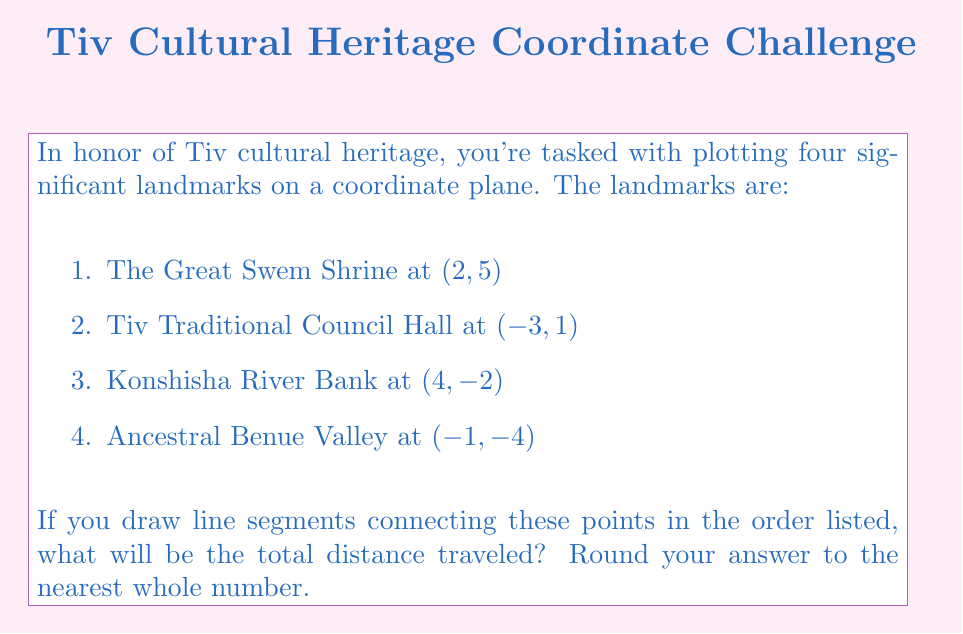Give your solution to this math problem. To solve this problem, we need to calculate the distances between consecutive points and sum them up. We'll use the distance formula between two points $(x_1, y_1)$ and $(x_2, y_2)$:

$$d = \sqrt{(x_2 - x_1)^2 + (y_2 - y_1)^2}$$

Let's calculate each distance:

1. From Great Swem Shrine (2, 5) to Tiv Traditional Council Hall (-3, 1):
   $$d_1 = \sqrt{(-3 - 2)^2 + (1 - 5)^2} = \sqrt{(-5)^2 + (-4)^2} = \sqrt{25 + 16} = \sqrt{41} \approx 6.40$$

2. From Tiv Traditional Council Hall (-3, 1) to Konshisha River Bank (4, -2):
   $$d_2 = \sqrt{(4 - (-3))^2 + (-2 - 1)^2} = \sqrt{7^2 + (-3)^2} = \sqrt{49 + 9} = \sqrt{58} \approx 7.62$$

3. From Konshisha River Bank (4, -2) to Ancestral Benue Valley (-1, -4):
   $$d_3 = \sqrt{(-1 - 4)^2 + (-4 - (-2))^2} = \sqrt{(-5)^2 + (-2)^2} = \sqrt{25 + 4} = \sqrt{29} \approx 5.39$$

4. From Ancestral Benue Valley (-1, -4) back to Great Swem Shrine (2, 5):
   $$d_4 = \sqrt{(2 - (-1))^2 + (5 - (-4))^2} = \sqrt{3^2 + 9^2} = \sqrt{9 + 81} = \sqrt{90} \approx 9.49$$

Now, we sum up all these distances:

$$\text{Total Distance} = d_1 + d_2 + d_3 + d_4 \approx 6.40 + 7.62 + 5.39 + 9.49 = 28.90$$

Rounding to the nearest whole number, we get 29.
Answer: 29 units 